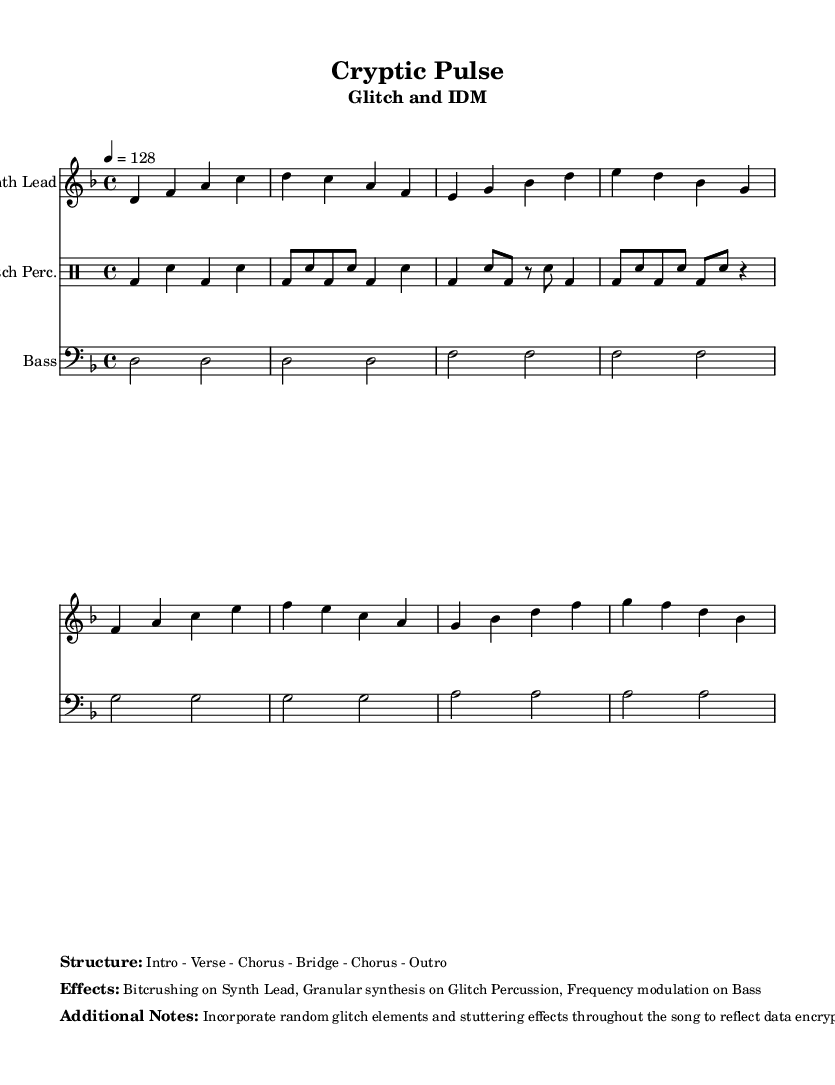What is the key signature of this music? The key signature is indicated at the beginning of the musical notation, and it shows two flats, which corresponds to D minor.
Answer: D minor What is the time signature of this piece? The time signature is stated at the beginning of the score, which shows 4 over 4, indicating that there are four beats in each measure.
Answer: 4/4 What is the tempo marking of the composition? The tempo marking is found near the beginning and shows a quarter note equals 128 beats per minute, indicating the speed of the music.
Answer: 128 What type of effects are used on the synth lead? The effects used are mentioned in the markup section below the musical notation, specifically referring to "Bitcrushing" being applied to create a distorted quality.
Answer: Bitcrushing What musical element is incorporated to reflect data encryption complexity? The notes in the additional notes section specifically mention using "random glitch elements and stuttering effects" throughout the song to mimic the complexity of data encryption.
Answer: Random glitch elements What kind of synthesis is applied to the glitch percussion? The additional notes indicate that "Granular synthesis" is used on the glitch percussion part, which gives it a unique texture and complexity.
Answer: Granular synthesis How many sections are in the structure of the song? The structure markup shows a breakdown of the song into five distinct sections: Intro, Verse, Chorus, Bridge, and Outro, confirming the song is segmented into five parts.
Answer: Five 